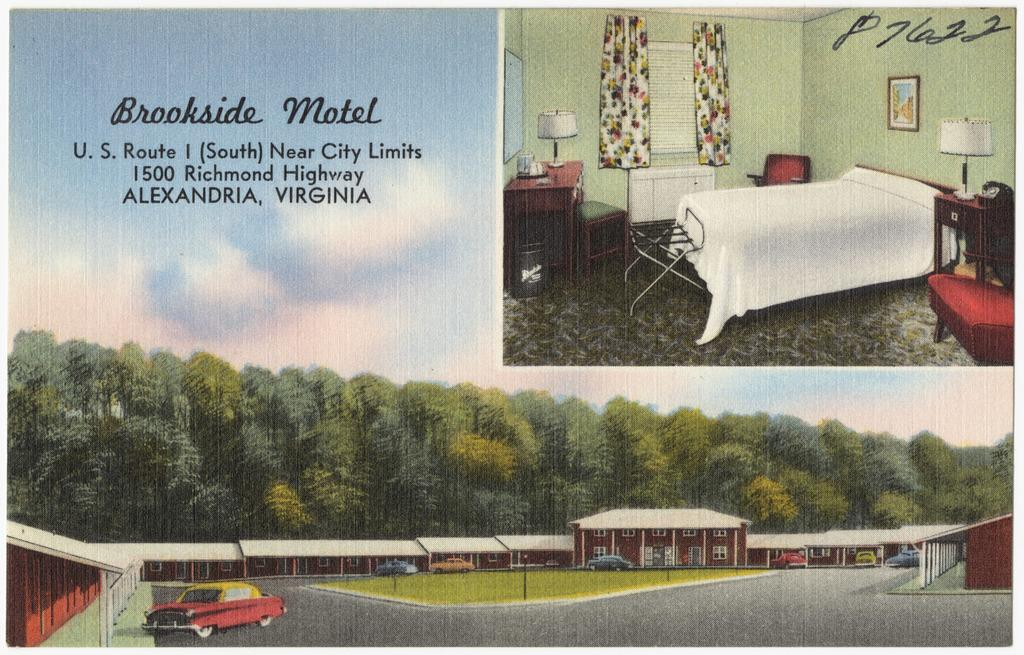What is the main subject of the painting in the image? The painting contains a depiction of trees. Are there any vehicles in the painting? Yes, there is a car in the painting. What other structures can be seen in the painting? There are buildings in the painting. What type of pathway is shown in the painting? The painting depicts a road. What can be seen in the sky in the painting? The sky is visible in the painting, and there are clouds present. What type of health advice is given in the painting? There is no health advice present in the painting; it is a depiction of trees, a car, buildings, a road, and the sky. What level of difficulty is associated with the painting? The painting does not have an associated level of difficulty; it is a static image. 